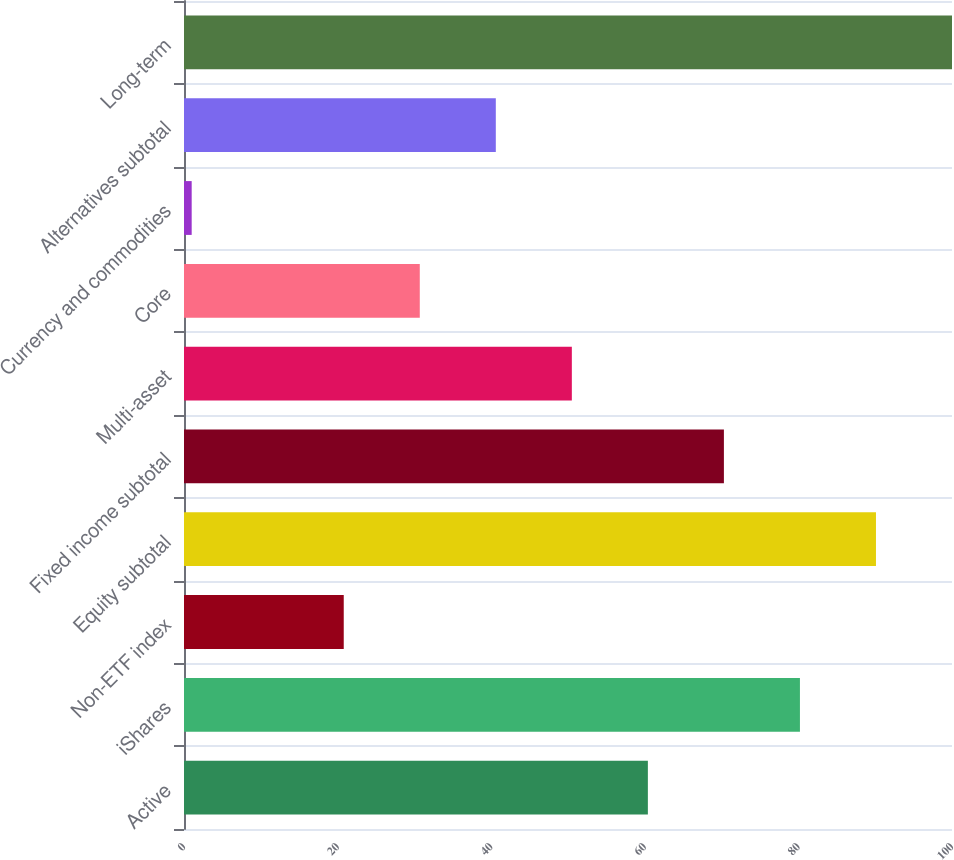<chart> <loc_0><loc_0><loc_500><loc_500><bar_chart><fcel>Active<fcel>iShares<fcel>Non-ETF index<fcel>Equity subtotal<fcel>Fixed income subtotal<fcel>Multi-asset<fcel>Core<fcel>Currency and commodities<fcel>Alternatives subtotal<fcel>Long-term<nl><fcel>60.4<fcel>80.2<fcel>20.8<fcel>90.1<fcel>70.3<fcel>50.5<fcel>30.7<fcel>1<fcel>40.6<fcel>100<nl></chart> 